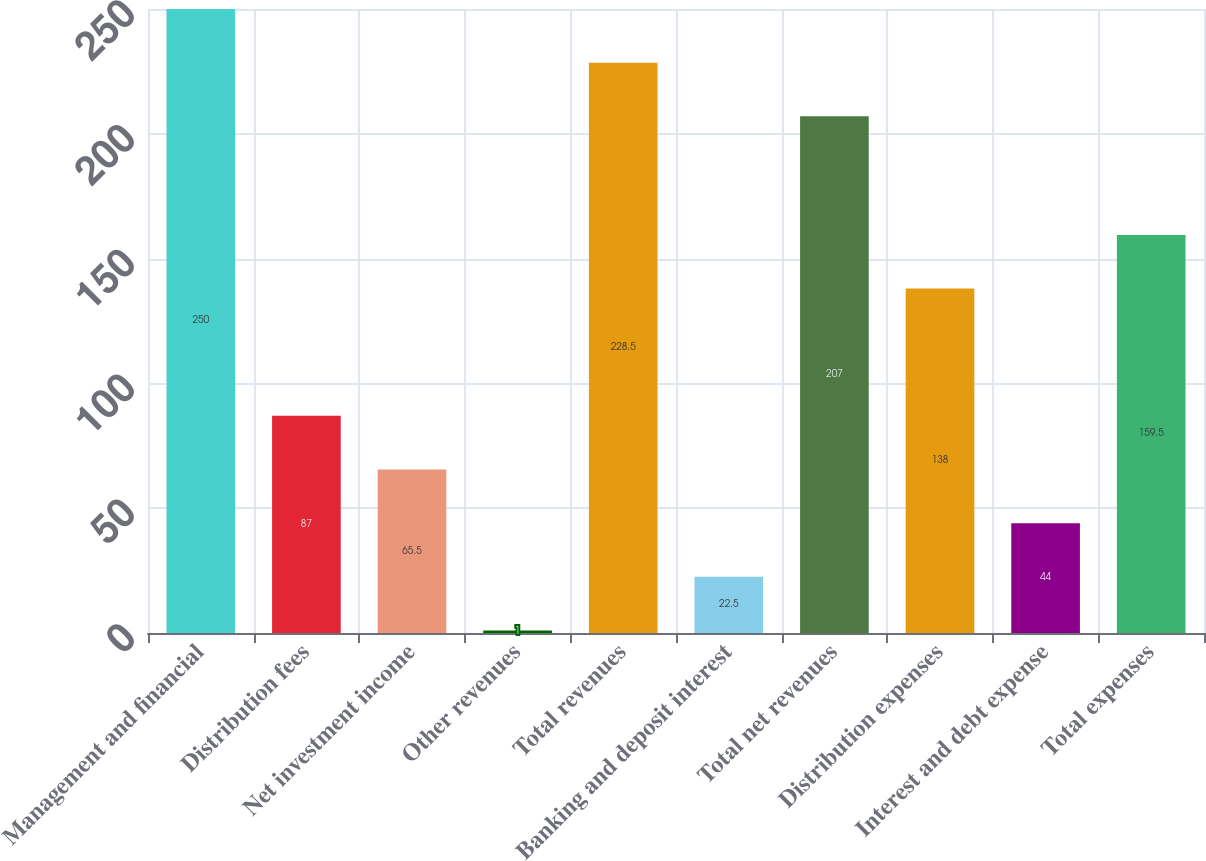Convert chart to OTSL. <chart><loc_0><loc_0><loc_500><loc_500><bar_chart><fcel>Management and financial<fcel>Distribution fees<fcel>Net investment income<fcel>Other revenues<fcel>Total revenues<fcel>Banking and deposit interest<fcel>Total net revenues<fcel>Distribution expenses<fcel>Interest and debt expense<fcel>Total expenses<nl><fcel>250<fcel>87<fcel>65.5<fcel>1<fcel>228.5<fcel>22.5<fcel>207<fcel>138<fcel>44<fcel>159.5<nl></chart> 